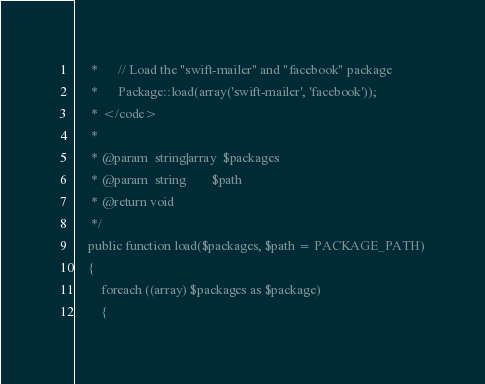Convert code to text. <code><loc_0><loc_0><loc_500><loc_500><_PHP_>	 *		// Load the "swift-mailer" and "facebook" package
	 *		Package::load(array('swift-mailer', 'facebook'));
	 * </code>
	 *
	 * @param  string|array  $packages
	 * @param  string        $path
	 * @return void
	 */
	public function load($packages, $path = PACKAGE_PATH)
	{
		foreach ((array) $packages as $package)
		{</code> 